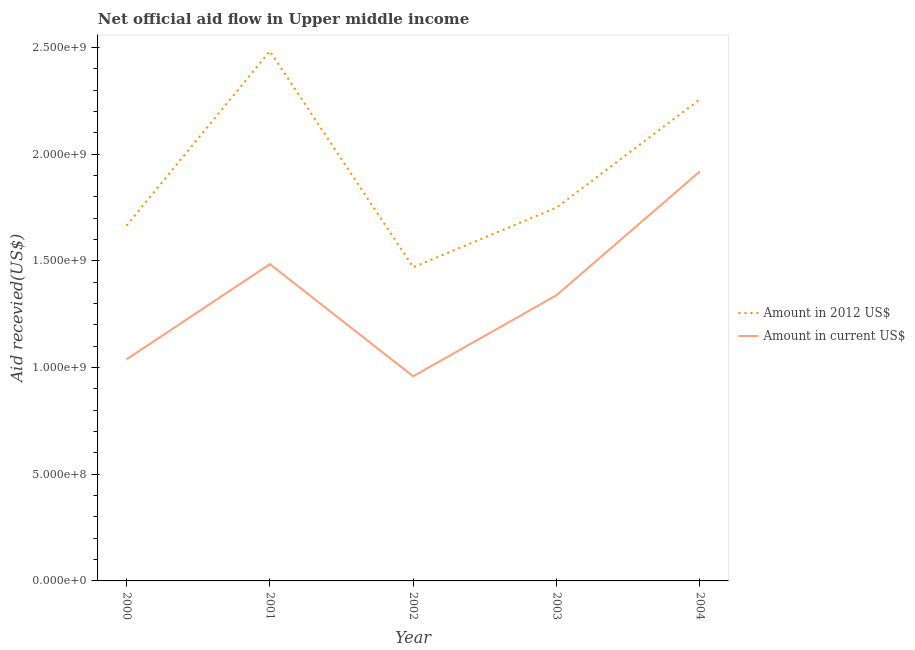How many different coloured lines are there?
Offer a terse response. 2. Is the number of lines equal to the number of legend labels?
Offer a terse response. Yes. What is the amount of aid received(expressed in us$) in 2002?
Your response must be concise. 9.59e+08. Across all years, what is the maximum amount of aid received(expressed in 2012 us$)?
Your response must be concise. 2.48e+09. Across all years, what is the minimum amount of aid received(expressed in us$)?
Your response must be concise. 9.59e+08. What is the total amount of aid received(expressed in us$) in the graph?
Keep it short and to the point. 6.74e+09. What is the difference between the amount of aid received(expressed in us$) in 2002 and that in 2003?
Provide a short and direct response. -3.80e+08. What is the difference between the amount of aid received(expressed in 2012 us$) in 2003 and the amount of aid received(expressed in us$) in 2004?
Offer a very short reply. -1.70e+08. What is the average amount of aid received(expressed in us$) per year?
Keep it short and to the point. 1.35e+09. In the year 2001, what is the difference between the amount of aid received(expressed in us$) and amount of aid received(expressed in 2012 us$)?
Make the answer very short. -9.98e+08. What is the ratio of the amount of aid received(expressed in us$) in 2000 to that in 2003?
Give a very brief answer. 0.78. Is the amount of aid received(expressed in us$) in 2000 less than that in 2001?
Give a very brief answer. Yes. Is the difference between the amount of aid received(expressed in us$) in 2000 and 2001 greater than the difference between the amount of aid received(expressed in 2012 us$) in 2000 and 2001?
Provide a short and direct response. Yes. What is the difference between the highest and the second highest amount of aid received(expressed in 2012 us$)?
Keep it short and to the point. 2.26e+08. What is the difference between the highest and the lowest amount of aid received(expressed in us$)?
Your response must be concise. 9.60e+08. Is the sum of the amount of aid received(expressed in us$) in 2001 and 2004 greater than the maximum amount of aid received(expressed in 2012 us$) across all years?
Offer a very short reply. Yes. Does the amount of aid received(expressed in 2012 us$) monotonically increase over the years?
Offer a very short reply. No. Is the amount of aid received(expressed in 2012 us$) strictly greater than the amount of aid received(expressed in us$) over the years?
Keep it short and to the point. Yes. How many lines are there?
Offer a very short reply. 2. How many years are there in the graph?
Make the answer very short. 5. Does the graph contain any zero values?
Keep it short and to the point. No. Does the graph contain grids?
Make the answer very short. No. What is the title of the graph?
Your answer should be compact. Net official aid flow in Upper middle income. What is the label or title of the X-axis?
Your answer should be very brief. Year. What is the label or title of the Y-axis?
Ensure brevity in your answer.  Aid recevied(US$). What is the Aid recevied(US$) in Amount in 2012 US$ in 2000?
Make the answer very short. 1.67e+09. What is the Aid recevied(US$) in Amount in current US$ in 2000?
Provide a succinct answer. 1.04e+09. What is the Aid recevied(US$) in Amount in 2012 US$ in 2001?
Ensure brevity in your answer.  2.48e+09. What is the Aid recevied(US$) in Amount in current US$ in 2001?
Your answer should be compact. 1.48e+09. What is the Aid recevied(US$) in Amount in 2012 US$ in 2002?
Your answer should be compact. 1.47e+09. What is the Aid recevied(US$) in Amount in current US$ in 2002?
Your answer should be compact. 9.59e+08. What is the Aid recevied(US$) in Amount in 2012 US$ in 2003?
Make the answer very short. 1.75e+09. What is the Aid recevied(US$) of Amount in current US$ in 2003?
Your response must be concise. 1.34e+09. What is the Aid recevied(US$) of Amount in 2012 US$ in 2004?
Provide a succinct answer. 2.26e+09. What is the Aid recevied(US$) of Amount in current US$ in 2004?
Provide a short and direct response. 1.92e+09. Across all years, what is the maximum Aid recevied(US$) of Amount in 2012 US$?
Offer a terse response. 2.48e+09. Across all years, what is the maximum Aid recevied(US$) of Amount in current US$?
Give a very brief answer. 1.92e+09. Across all years, what is the minimum Aid recevied(US$) in Amount in 2012 US$?
Your answer should be compact. 1.47e+09. Across all years, what is the minimum Aid recevied(US$) in Amount in current US$?
Provide a short and direct response. 9.59e+08. What is the total Aid recevied(US$) in Amount in 2012 US$ in the graph?
Your response must be concise. 9.62e+09. What is the total Aid recevied(US$) of Amount in current US$ in the graph?
Your response must be concise. 6.74e+09. What is the difference between the Aid recevied(US$) in Amount in 2012 US$ in 2000 and that in 2001?
Your response must be concise. -8.18e+08. What is the difference between the Aid recevied(US$) of Amount in current US$ in 2000 and that in 2001?
Provide a short and direct response. -4.46e+08. What is the difference between the Aid recevied(US$) of Amount in 2012 US$ in 2000 and that in 2002?
Your response must be concise. 1.95e+08. What is the difference between the Aid recevied(US$) in Amount in current US$ in 2000 and that in 2002?
Give a very brief answer. 7.93e+07. What is the difference between the Aid recevied(US$) of Amount in 2012 US$ in 2000 and that in 2003?
Offer a very short reply. -8.44e+07. What is the difference between the Aid recevied(US$) in Amount in current US$ in 2000 and that in 2003?
Offer a very short reply. -3.01e+08. What is the difference between the Aid recevied(US$) in Amount in 2012 US$ in 2000 and that in 2004?
Give a very brief answer. -5.92e+08. What is the difference between the Aid recevied(US$) of Amount in current US$ in 2000 and that in 2004?
Your answer should be very brief. -8.81e+08. What is the difference between the Aid recevied(US$) in Amount in 2012 US$ in 2001 and that in 2002?
Your answer should be very brief. 1.01e+09. What is the difference between the Aid recevied(US$) in Amount in current US$ in 2001 and that in 2002?
Make the answer very short. 5.26e+08. What is the difference between the Aid recevied(US$) in Amount in 2012 US$ in 2001 and that in 2003?
Offer a terse response. 7.33e+08. What is the difference between the Aid recevied(US$) of Amount in current US$ in 2001 and that in 2003?
Keep it short and to the point. 1.46e+08. What is the difference between the Aid recevied(US$) in Amount in 2012 US$ in 2001 and that in 2004?
Ensure brevity in your answer.  2.26e+08. What is the difference between the Aid recevied(US$) of Amount in current US$ in 2001 and that in 2004?
Your answer should be very brief. -4.35e+08. What is the difference between the Aid recevied(US$) of Amount in 2012 US$ in 2002 and that in 2003?
Give a very brief answer. -2.79e+08. What is the difference between the Aid recevied(US$) of Amount in current US$ in 2002 and that in 2003?
Make the answer very short. -3.80e+08. What is the difference between the Aid recevied(US$) of Amount in 2012 US$ in 2002 and that in 2004?
Ensure brevity in your answer.  -7.87e+08. What is the difference between the Aid recevied(US$) in Amount in current US$ in 2002 and that in 2004?
Provide a short and direct response. -9.60e+08. What is the difference between the Aid recevied(US$) of Amount in 2012 US$ in 2003 and that in 2004?
Provide a short and direct response. -5.07e+08. What is the difference between the Aid recevied(US$) in Amount in current US$ in 2003 and that in 2004?
Your answer should be compact. -5.80e+08. What is the difference between the Aid recevied(US$) of Amount in 2012 US$ in 2000 and the Aid recevied(US$) of Amount in current US$ in 2001?
Provide a short and direct response. 1.81e+08. What is the difference between the Aid recevied(US$) of Amount in 2012 US$ in 2000 and the Aid recevied(US$) of Amount in current US$ in 2002?
Offer a terse response. 7.06e+08. What is the difference between the Aid recevied(US$) of Amount in 2012 US$ in 2000 and the Aid recevied(US$) of Amount in current US$ in 2003?
Provide a succinct answer. 3.26e+08. What is the difference between the Aid recevied(US$) of Amount in 2012 US$ in 2000 and the Aid recevied(US$) of Amount in current US$ in 2004?
Make the answer very short. -2.54e+08. What is the difference between the Aid recevied(US$) in Amount in 2012 US$ in 2001 and the Aid recevied(US$) in Amount in current US$ in 2002?
Offer a terse response. 1.52e+09. What is the difference between the Aid recevied(US$) in Amount in 2012 US$ in 2001 and the Aid recevied(US$) in Amount in current US$ in 2003?
Offer a very short reply. 1.14e+09. What is the difference between the Aid recevied(US$) of Amount in 2012 US$ in 2001 and the Aid recevied(US$) of Amount in current US$ in 2004?
Give a very brief answer. 5.64e+08. What is the difference between the Aid recevied(US$) in Amount in 2012 US$ in 2002 and the Aid recevied(US$) in Amount in current US$ in 2003?
Give a very brief answer. 1.31e+08. What is the difference between the Aid recevied(US$) in Amount in 2012 US$ in 2002 and the Aid recevied(US$) in Amount in current US$ in 2004?
Your answer should be compact. -4.49e+08. What is the difference between the Aid recevied(US$) in Amount in 2012 US$ in 2003 and the Aid recevied(US$) in Amount in current US$ in 2004?
Offer a terse response. -1.70e+08. What is the average Aid recevied(US$) of Amount in 2012 US$ per year?
Keep it short and to the point. 1.92e+09. What is the average Aid recevied(US$) of Amount in current US$ per year?
Your answer should be compact. 1.35e+09. In the year 2000, what is the difference between the Aid recevied(US$) of Amount in 2012 US$ and Aid recevied(US$) of Amount in current US$?
Your answer should be compact. 6.27e+08. In the year 2001, what is the difference between the Aid recevied(US$) in Amount in 2012 US$ and Aid recevied(US$) in Amount in current US$?
Provide a succinct answer. 9.98e+08. In the year 2002, what is the difference between the Aid recevied(US$) of Amount in 2012 US$ and Aid recevied(US$) of Amount in current US$?
Provide a short and direct response. 5.11e+08. In the year 2003, what is the difference between the Aid recevied(US$) in Amount in 2012 US$ and Aid recevied(US$) in Amount in current US$?
Provide a short and direct response. 4.11e+08. In the year 2004, what is the difference between the Aid recevied(US$) of Amount in 2012 US$ and Aid recevied(US$) of Amount in current US$?
Give a very brief answer. 3.38e+08. What is the ratio of the Aid recevied(US$) in Amount in 2012 US$ in 2000 to that in 2001?
Offer a terse response. 0.67. What is the ratio of the Aid recevied(US$) of Amount in current US$ in 2000 to that in 2001?
Your answer should be very brief. 0.7. What is the ratio of the Aid recevied(US$) in Amount in 2012 US$ in 2000 to that in 2002?
Your answer should be compact. 1.13. What is the ratio of the Aid recevied(US$) in Amount in current US$ in 2000 to that in 2002?
Offer a terse response. 1.08. What is the ratio of the Aid recevied(US$) in Amount in 2012 US$ in 2000 to that in 2003?
Ensure brevity in your answer.  0.95. What is the ratio of the Aid recevied(US$) in Amount in current US$ in 2000 to that in 2003?
Make the answer very short. 0.78. What is the ratio of the Aid recevied(US$) of Amount in 2012 US$ in 2000 to that in 2004?
Your response must be concise. 0.74. What is the ratio of the Aid recevied(US$) of Amount in current US$ in 2000 to that in 2004?
Your answer should be compact. 0.54. What is the ratio of the Aid recevied(US$) in Amount in 2012 US$ in 2001 to that in 2002?
Your response must be concise. 1.69. What is the ratio of the Aid recevied(US$) in Amount in current US$ in 2001 to that in 2002?
Your answer should be very brief. 1.55. What is the ratio of the Aid recevied(US$) of Amount in 2012 US$ in 2001 to that in 2003?
Your response must be concise. 1.42. What is the ratio of the Aid recevied(US$) in Amount in current US$ in 2001 to that in 2003?
Make the answer very short. 1.11. What is the ratio of the Aid recevied(US$) in Amount in 2012 US$ in 2001 to that in 2004?
Provide a succinct answer. 1.1. What is the ratio of the Aid recevied(US$) in Amount in current US$ in 2001 to that in 2004?
Provide a succinct answer. 0.77. What is the ratio of the Aid recevied(US$) in Amount in 2012 US$ in 2002 to that in 2003?
Give a very brief answer. 0.84. What is the ratio of the Aid recevied(US$) in Amount in current US$ in 2002 to that in 2003?
Keep it short and to the point. 0.72. What is the ratio of the Aid recevied(US$) of Amount in 2012 US$ in 2002 to that in 2004?
Keep it short and to the point. 0.65. What is the ratio of the Aid recevied(US$) of Amount in current US$ in 2002 to that in 2004?
Provide a short and direct response. 0.5. What is the ratio of the Aid recevied(US$) in Amount in 2012 US$ in 2003 to that in 2004?
Provide a succinct answer. 0.78. What is the ratio of the Aid recevied(US$) in Amount in current US$ in 2003 to that in 2004?
Give a very brief answer. 0.7. What is the difference between the highest and the second highest Aid recevied(US$) of Amount in 2012 US$?
Keep it short and to the point. 2.26e+08. What is the difference between the highest and the second highest Aid recevied(US$) of Amount in current US$?
Make the answer very short. 4.35e+08. What is the difference between the highest and the lowest Aid recevied(US$) of Amount in 2012 US$?
Keep it short and to the point. 1.01e+09. What is the difference between the highest and the lowest Aid recevied(US$) of Amount in current US$?
Keep it short and to the point. 9.60e+08. 